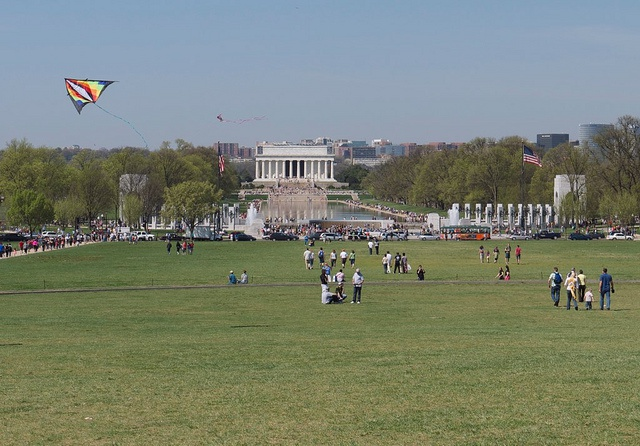Describe the objects in this image and their specific colors. I can see people in darkgray, gray, olive, and black tones, car in darkgray, gray, black, and darkgreen tones, kite in darkgray, gray, khaki, and lavender tones, bus in darkgray, gray, black, and brown tones, and kite in darkgray and gray tones in this image. 